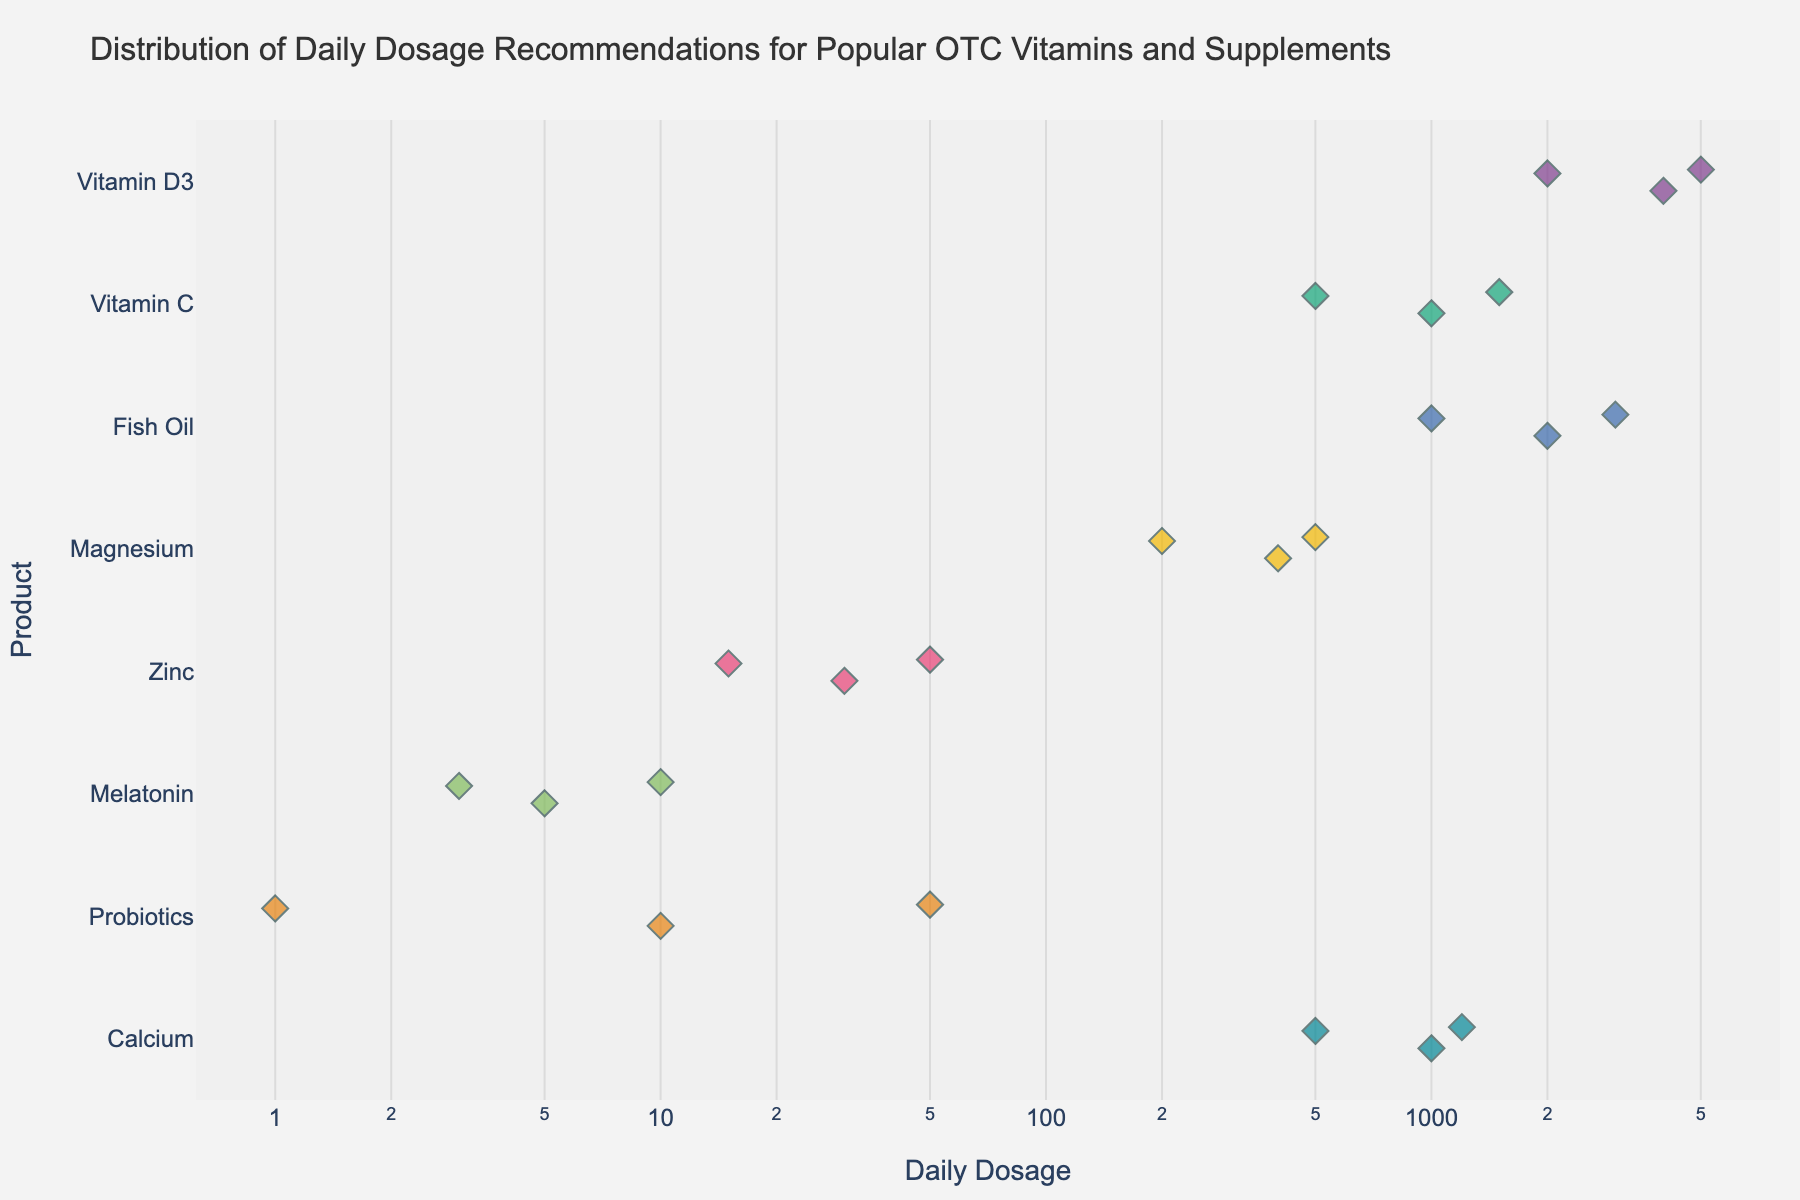What's the title of the figure? The title is located at the top of the figure and provides a summary of what the figure represents.
Answer: Distribution of Daily Dosage Recommendations for Popular OTC Vitamins and Supplements What is the daily dosage range for Vitamin D3? Locate the points for Vitamin D3 on the strip plot along the x-axis and observe the minimum and maximum values. They range from 2000 IU to 5000 IU.
Answer: 2000 IU to 5000 IU How many data points are there for Vitamin C? Count the number of distinct points along the Vitamin C row on the y-axis of the strip plot.
Answer: 3 Which product has the highest daily dosage recommendation? Identify the rightmost point on the x-axis and see which product it corresponds to on the y-axis. This is Probiotics with 50 billion CFU.
Answer: Probiotics What is the average daily dosage of Fish Oil? Identify the data points for Fish Oil (1000 mg, 2000 mg, 3000 mg). Calculate the average: (1000 + 2000 + 3000) / 3 = 2000 mg.
Answer: 2000 mg Which product shows the greatest variability in dosage recommendations? Compare the spread of points along the x-axis for each product. The product with the widest spread, which is Probiotics (1 billion CFU to 50 billion CFU), shows the greatest variability.
Answer: Probiotics Is there any product that has the same value for all dosage recommendations? Look for products that have multiple points stacked vertically with the same x-coordinate, indicating identical dosages. None of the products meet this criterion.
Answer: No What is the combined range of daily dosages for all products in milligrams? Convert all dosages to mg where applicable and determine the overall minimum and maximum values. The smallest relevant value is Magnesium at 200 mg and the largest is Calcium at 1200 mg.
Answer: 200 mg to 1200 mg How does the dosage distribution for Melatonin compare to that of Calcium? Melatonin ranges from 3 mg to 10 mg, whereas Calcium ranges from 500 mg to 1200 mg. Melatonin’s range is narrower and generally lower than that of Calcium.
Answer: Melatonin has a narrower and lower dosage range compared to Calcium 